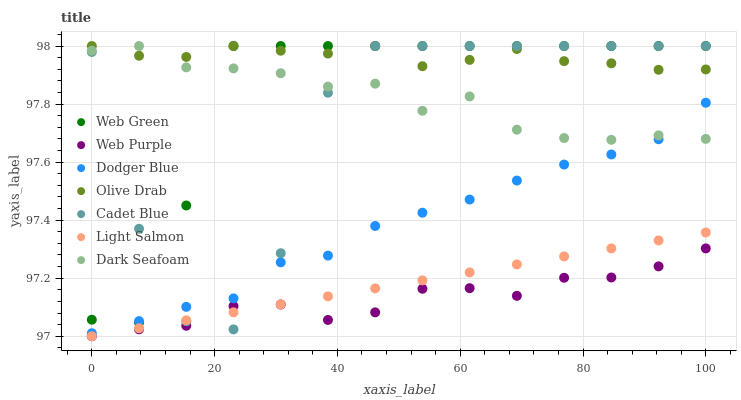Does Web Purple have the minimum area under the curve?
Answer yes or no. Yes. Does Olive Drab have the maximum area under the curve?
Answer yes or no. Yes. Does Cadet Blue have the minimum area under the curve?
Answer yes or no. No. Does Cadet Blue have the maximum area under the curve?
Answer yes or no. No. Is Light Salmon the smoothest?
Answer yes or no. Yes. Is Cadet Blue the roughest?
Answer yes or no. Yes. Is Dark Seafoam the smoothest?
Answer yes or no. No. Is Dark Seafoam the roughest?
Answer yes or no. No. Does Light Salmon have the lowest value?
Answer yes or no. Yes. Does Cadet Blue have the lowest value?
Answer yes or no. No. Does Olive Drab have the highest value?
Answer yes or no. Yes. Does Web Purple have the highest value?
Answer yes or no. No. Is Web Purple less than Dodger Blue?
Answer yes or no. Yes. Is Dodger Blue greater than Web Purple?
Answer yes or no. Yes. Does Dark Seafoam intersect Dodger Blue?
Answer yes or no. Yes. Is Dark Seafoam less than Dodger Blue?
Answer yes or no. No. Is Dark Seafoam greater than Dodger Blue?
Answer yes or no. No. Does Web Purple intersect Dodger Blue?
Answer yes or no. No. 